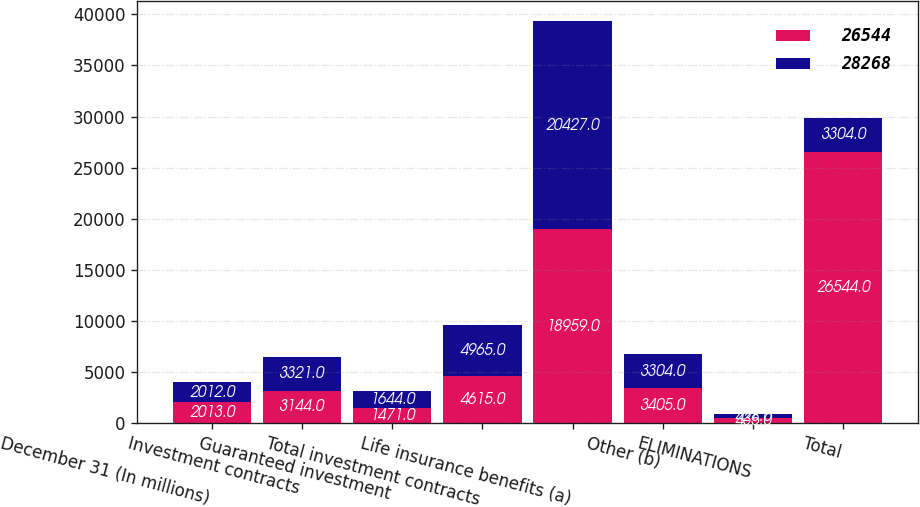Convert chart to OTSL. <chart><loc_0><loc_0><loc_500><loc_500><stacked_bar_chart><ecel><fcel>December 31 (In millions)<fcel>Investment contracts<fcel>Guaranteed investment<fcel>Total investment contracts<fcel>Life insurance benefits (a)<fcel>Other (b)<fcel>ELIMINATIONS<fcel>Total<nl><fcel>26544<fcel>2013<fcel>3144<fcel>1471<fcel>4615<fcel>18959<fcel>3405<fcel>435<fcel>26544<nl><fcel>28268<fcel>2012<fcel>3321<fcel>1644<fcel>4965<fcel>20427<fcel>3304<fcel>428<fcel>3304<nl></chart> 